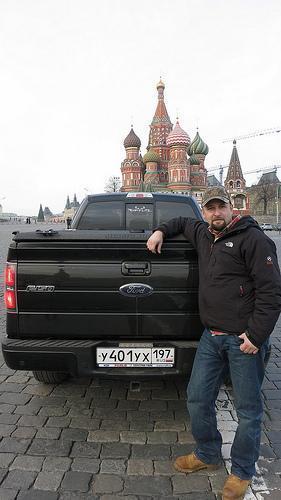How many purple trucks are there?
Give a very brief answer. 0. 